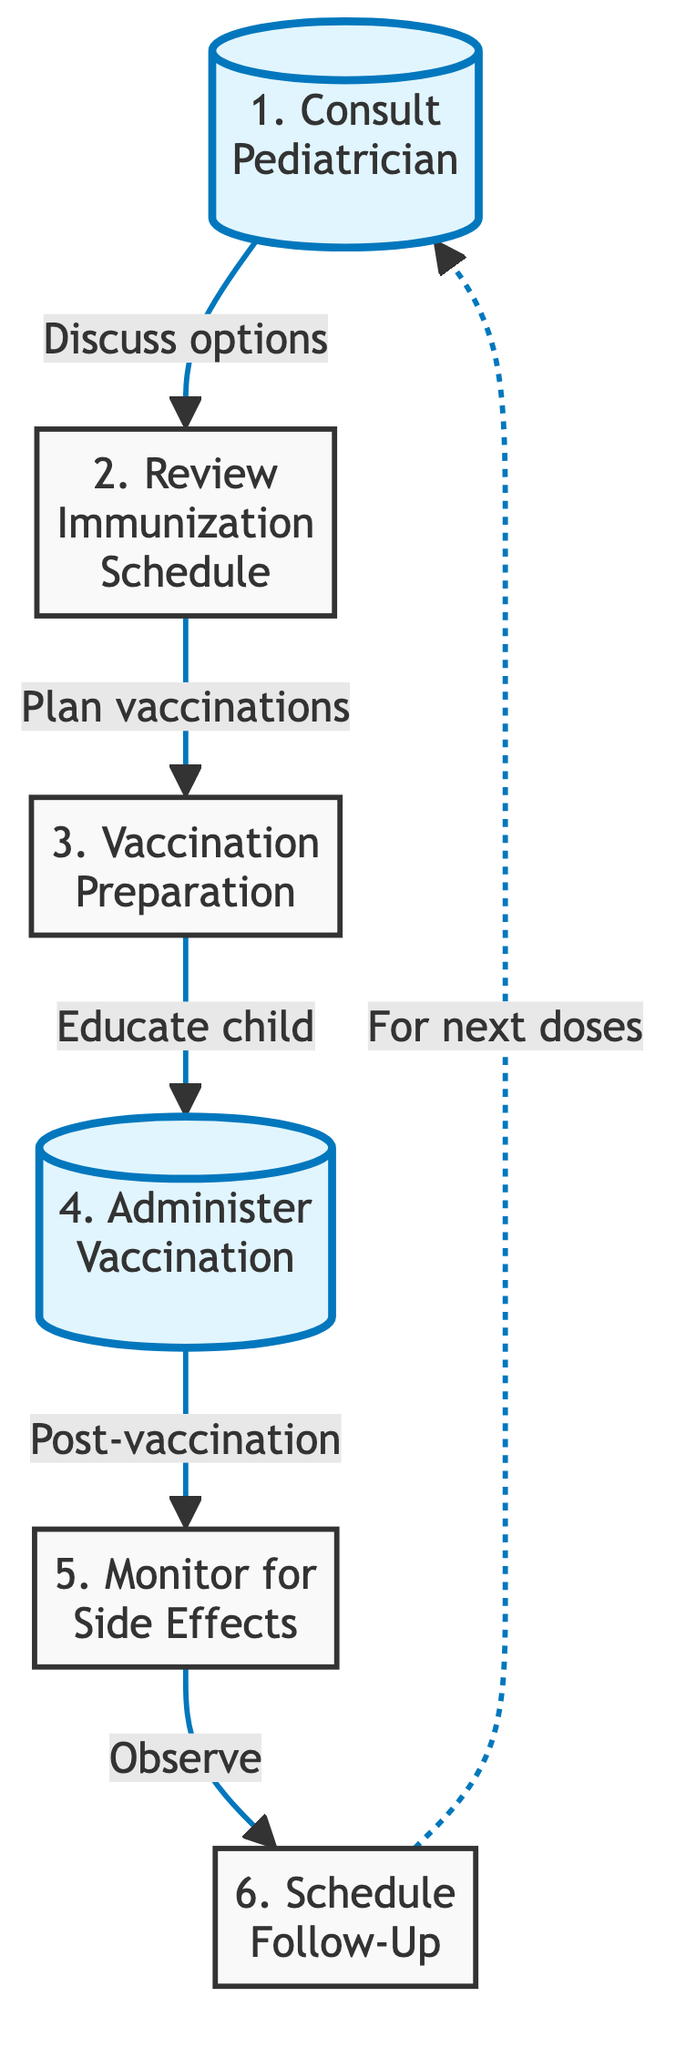What's the first step in the vaccination schedule? The first step identified in the flow chart is "Consult Pediatrician."
Answer: Consult Pediatrician How many nodes are in this flow chart? There are six nodes representing distinct steps in the vaccination schedule process.
Answer: 6 What is the outcome of the vaccination preparation step? The outcome of the vaccination preparation step is to "Educate child" before moving to the vaccination administration step.
Answer: Educate child What is the relationship between "Monitor for Side Effects" and "Schedule Follow-Up"? The relationship is that after monitoring for side effects, the next step is to schedule a follow-up for any additional doses required.
Answer: Schedule Follow-Up Which steps involve visiting the clinic? The step that involves visiting the clinic is "Administer Vaccination," where vaccines are administered by a qualified health professional.
Answer: Administer Vaccination What step follows "Administer Vaccination"? The step that follows "Administer Vaccination" is "Monitor for Side Effects."
Answer: Monitor for Side Effects What is the last step in the vaccination schedule? The last step in the vaccination schedule flow chart is "Schedule Follow-Up."
Answer: Schedule Follow-Up How does "Schedule Follow-Up" relate to "Consult Pediatrician"? "Schedule Follow-Up" relates to "Consult Pediatrician" as it indicates that for the next doses, parents will revisit the pediatrician for further discussion.
Answer: For next doses What is the purpose of the "Vaccination Preparation" step? The purpose of the "Vaccination Preparation" step is to prepare the child by explaining the importance of vaccines in simple terms.
Answer: Explain importance of vaccines 